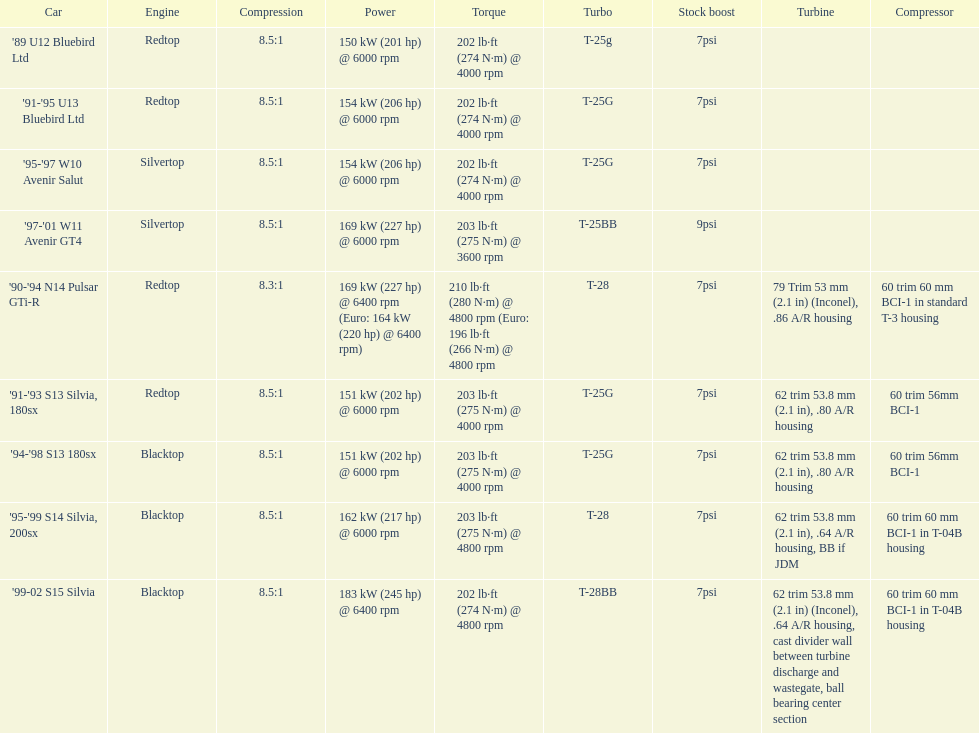Which car possesses an original boost exceeding 7psi? '97-'01 W11 Avenir GT4. 